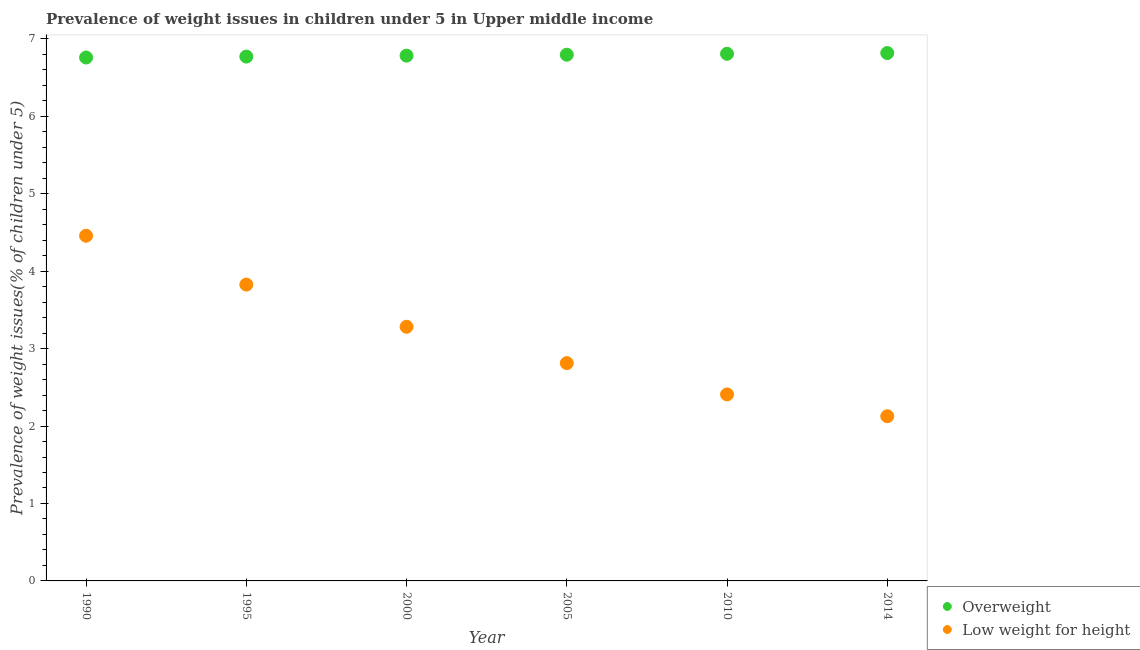Is the number of dotlines equal to the number of legend labels?
Your answer should be compact. Yes. What is the percentage of underweight children in 1990?
Ensure brevity in your answer.  4.46. Across all years, what is the maximum percentage of overweight children?
Provide a succinct answer. 6.82. Across all years, what is the minimum percentage of underweight children?
Your answer should be very brief. 2.13. In which year was the percentage of underweight children minimum?
Offer a very short reply. 2014. What is the total percentage of overweight children in the graph?
Keep it short and to the point. 40.73. What is the difference between the percentage of overweight children in 2005 and that in 2014?
Your response must be concise. -0.02. What is the difference between the percentage of overweight children in 2000 and the percentage of underweight children in 2005?
Keep it short and to the point. 3.97. What is the average percentage of underweight children per year?
Ensure brevity in your answer.  3.15. In the year 1995, what is the difference between the percentage of overweight children and percentage of underweight children?
Offer a terse response. 2.94. In how many years, is the percentage of underweight children greater than 3 %?
Your answer should be very brief. 3. What is the ratio of the percentage of overweight children in 2000 to that in 2014?
Your response must be concise. 1. What is the difference between the highest and the second highest percentage of overweight children?
Offer a terse response. 0.01. What is the difference between the highest and the lowest percentage of underweight children?
Ensure brevity in your answer.  2.33. In how many years, is the percentage of underweight children greater than the average percentage of underweight children taken over all years?
Keep it short and to the point. 3. Is the sum of the percentage of underweight children in 2000 and 2010 greater than the maximum percentage of overweight children across all years?
Offer a terse response. No. Does the percentage of overweight children monotonically increase over the years?
Keep it short and to the point. Yes. Is the percentage of overweight children strictly greater than the percentage of underweight children over the years?
Your answer should be compact. Yes. Is the percentage of overweight children strictly less than the percentage of underweight children over the years?
Give a very brief answer. No. How many dotlines are there?
Your response must be concise. 2. How many years are there in the graph?
Keep it short and to the point. 6. Are the values on the major ticks of Y-axis written in scientific E-notation?
Offer a very short reply. No. How many legend labels are there?
Offer a terse response. 2. What is the title of the graph?
Provide a succinct answer. Prevalence of weight issues in children under 5 in Upper middle income. What is the label or title of the Y-axis?
Provide a succinct answer. Prevalence of weight issues(% of children under 5). What is the Prevalence of weight issues(% of children under 5) in Overweight in 1990?
Provide a short and direct response. 6.76. What is the Prevalence of weight issues(% of children under 5) of Low weight for height in 1990?
Provide a short and direct response. 4.46. What is the Prevalence of weight issues(% of children under 5) of Overweight in 1995?
Offer a very short reply. 6.77. What is the Prevalence of weight issues(% of children under 5) of Low weight for height in 1995?
Make the answer very short. 3.83. What is the Prevalence of weight issues(% of children under 5) in Overweight in 2000?
Your answer should be very brief. 6.78. What is the Prevalence of weight issues(% of children under 5) in Low weight for height in 2000?
Give a very brief answer. 3.28. What is the Prevalence of weight issues(% of children under 5) in Overweight in 2005?
Offer a terse response. 6.8. What is the Prevalence of weight issues(% of children under 5) of Low weight for height in 2005?
Keep it short and to the point. 2.81. What is the Prevalence of weight issues(% of children under 5) of Overweight in 2010?
Ensure brevity in your answer.  6.81. What is the Prevalence of weight issues(% of children under 5) in Low weight for height in 2010?
Make the answer very short. 2.41. What is the Prevalence of weight issues(% of children under 5) of Overweight in 2014?
Ensure brevity in your answer.  6.82. What is the Prevalence of weight issues(% of children under 5) in Low weight for height in 2014?
Ensure brevity in your answer.  2.13. Across all years, what is the maximum Prevalence of weight issues(% of children under 5) in Overweight?
Your answer should be very brief. 6.82. Across all years, what is the maximum Prevalence of weight issues(% of children under 5) in Low weight for height?
Ensure brevity in your answer.  4.46. Across all years, what is the minimum Prevalence of weight issues(% of children under 5) in Overweight?
Provide a short and direct response. 6.76. Across all years, what is the minimum Prevalence of weight issues(% of children under 5) in Low weight for height?
Ensure brevity in your answer.  2.13. What is the total Prevalence of weight issues(% of children under 5) in Overweight in the graph?
Make the answer very short. 40.73. What is the total Prevalence of weight issues(% of children under 5) in Low weight for height in the graph?
Provide a short and direct response. 18.91. What is the difference between the Prevalence of weight issues(% of children under 5) in Overweight in 1990 and that in 1995?
Offer a terse response. -0.01. What is the difference between the Prevalence of weight issues(% of children under 5) in Low weight for height in 1990 and that in 1995?
Your response must be concise. 0.63. What is the difference between the Prevalence of weight issues(% of children under 5) of Overweight in 1990 and that in 2000?
Provide a succinct answer. -0.02. What is the difference between the Prevalence of weight issues(% of children under 5) in Low weight for height in 1990 and that in 2000?
Your response must be concise. 1.18. What is the difference between the Prevalence of weight issues(% of children under 5) in Overweight in 1990 and that in 2005?
Provide a short and direct response. -0.04. What is the difference between the Prevalence of weight issues(% of children under 5) of Low weight for height in 1990 and that in 2005?
Your answer should be compact. 1.65. What is the difference between the Prevalence of weight issues(% of children under 5) in Overweight in 1990 and that in 2010?
Your answer should be compact. -0.05. What is the difference between the Prevalence of weight issues(% of children under 5) of Low weight for height in 1990 and that in 2010?
Your answer should be very brief. 2.05. What is the difference between the Prevalence of weight issues(% of children under 5) in Overweight in 1990 and that in 2014?
Offer a terse response. -0.06. What is the difference between the Prevalence of weight issues(% of children under 5) of Low weight for height in 1990 and that in 2014?
Offer a very short reply. 2.33. What is the difference between the Prevalence of weight issues(% of children under 5) of Overweight in 1995 and that in 2000?
Your answer should be very brief. -0.01. What is the difference between the Prevalence of weight issues(% of children under 5) in Low weight for height in 1995 and that in 2000?
Provide a short and direct response. 0.54. What is the difference between the Prevalence of weight issues(% of children under 5) in Overweight in 1995 and that in 2005?
Keep it short and to the point. -0.02. What is the difference between the Prevalence of weight issues(% of children under 5) in Low weight for height in 1995 and that in 2005?
Make the answer very short. 1.01. What is the difference between the Prevalence of weight issues(% of children under 5) in Overweight in 1995 and that in 2010?
Your answer should be compact. -0.04. What is the difference between the Prevalence of weight issues(% of children under 5) in Low weight for height in 1995 and that in 2010?
Offer a very short reply. 1.42. What is the difference between the Prevalence of weight issues(% of children under 5) in Overweight in 1995 and that in 2014?
Provide a short and direct response. -0.05. What is the difference between the Prevalence of weight issues(% of children under 5) of Low weight for height in 1995 and that in 2014?
Ensure brevity in your answer.  1.7. What is the difference between the Prevalence of weight issues(% of children under 5) in Overweight in 2000 and that in 2005?
Provide a short and direct response. -0.01. What is the difference between the Prevalence of weight issues(% of children under 5) of Low weight for height in 2000 and that in 2005?
Offer a terse response. 0.47. What is the difference between the Prevalence of weight issues(% of children under 5) in Overweight in 2000 and that in 2010?
Your answer should be very brief. -0.02. What is the difference between the Prevalence of weight issues(% of children under 5) in Low weight for height in 2000 and that in 2010?
Provide a short and direct response. 0.87. What is the difference between the Prevalence of weight issues(% of children under 5) of Overweight in 2000 and that in 2014?
Make the answer very short. -0.03. What is the difference between the Prevalence of weight issues(% of children under 5) in Low weight for height in 2000 and that in 2014?
Keep it short and to the point. 1.16. What is the difference between the Prevalence of weight issues(% of children under 5) of Overweight in 2005 and that in 2010?
Ensure brevity in your answer.  -0.01. What is the difference between the Prevalence of weight issues(% of children under 5) of Low weight for height in 2005 and that in 2010?
Ensure brevity in your answer.  0.4. What is the difference between the Prevalence of weight issues(% of children under 5) of Overweight in 2005 and that in 2014?
Your response must be concise. -0.02. What is the difference between the Prevalence of weight issues(% of children under 5) of Low weight for height in 2005 and that in 2014?
Make the answer very short. 0.69. What is the difference between the Prevalence of weight issues(% of children under 5) of Overweight in 2010 and that in 2014?
Your answer should be very brief. -0.01. What is the difference between the Prevalence of weight issues(% of children under 5) of Low weight for height in 2010 and that in 2014?
Your answer should be very brief. 0.28. What is the difference between the Prevalence of weight issues(% of children under 5) of Overweight in 1990 and the Prevalence of weight issues(% of children under 5) of Low weight for height in 1995?
Offer a terse response. 2.93. What is the difference between the Prevalence of weight issues(% of children under 5) of Overweight in 1990 and the Prevalence of weight issues(% of children under 5) of Low weight for height in 2000?
Give a very brief answer. 3.48. What is the difference between the Prevalence of weight issues(% of children under 5) of Overweight in 1990 and the Prevalence of weight issues(% of children under 5) of Low weight for height in 2005?
Provide a succinct answer. 3.95. What is the difference between the Prevalence of weight issues(% of children under 5) of Overweight in 1990 and the Prevalence of weight issues(% of children under 5) of Low weight for height in 2010?
Give a very brief answer. 4.35. What is the difference between the Prevalence of weight issues(% of children under 5) in Overweight in 1990 and the Prevalence of weight issues(% of children under 5) in Low weight for height in 2014?
Offer a terse response. 4.63. What is the difference between the Prevalence of weight issues(% of children under 5) of Overweight in 1995 and the Prevalence of weight issues(% of children under 5) of Low weight for height in 2000?
Ensure brevity in your answer.  3.49. What is the difference between the Prevalence of weight issues(% of children under 5) of Overweight in 1995 and the Prevalence of weight issues(% of children under 5) of Low weight for height in 2005?
Provide a succinct answer. 3.96. What is the difference between the Prevalence of weight issues(% of children under 5) in Overweight in 1995 and the Prevalence of weight issues(% of children under 5) in Low weight for height in 2010?
Your answer should be very brief. 4.36. What is the difference between the Prevalence of weight issues(% of children under 5) of Overweight in 1995 and the Prevalence of weight issues(% of children under 5) of Low weight for height in 2014?
Your answer should be compact. 4.64. What is the difference between the Prevalence of weight issues(% of children under 5) of Overweight in 2000 and the Prevalence of weight issues(% of children under 5) of Low weight for height in 2005?
Offer a terse response. 3.97. What is the difference between the Prevalence of weight issues(% of children under 5) in Overweight in 2000 and the Prevalence of weight issues(% of children under 5) in Low weight for height in 2010?
Keep it short and to the point. 4.37. What is the difference between the Prevalence of weight issues(% of children under 5) of Overweight in 2000 and the Prevalence of weight issues(% of children under 5) of Low weight for height in 2014?
Provide a short and direct response. 4.66. What is the difference between the Prevalence of weight issues(% of children under 5) of Overweight in 2005 and the Prevalence of weight issues(% of children under 5) of Low weight for height in 2010?
Provide a short and direct response. 4.39. What is the difference between the Prevalence of weight issues(% of children under 5) of Overweight in 2005 and the Prevalence of weight issues(% of children under 5) of Low weight for height in 2014?
Your answer should be compact. 4.67. What is the difference between the Prevalence of weight issues(% of children under 5) of Overweight in 2010 and the Prevalence of weight issues(% of children under 5) of Low weight for height in 2014?
Give a very brief answer. 4.68. What is the average Prevalence of weight issues(% of children under 5) in Overweight per year?
Your response must be concise. 6.79. What is the average Prevalence of weight issues(% of children under 5) of Low weight for height per year?
Your response must be concise. 3.15. In the year 1990, what is the difference between the Prevalence of weight issues(% of children under 5) of Overweight and Prevalence of weight issues(% of children under 5) of Low weight for height?
Your answer should be very brief. 2.3. In the year 1995, what is the difference between the Prevalence of weight issues(% of children under 5) in Overweight and Prevalence of weight issues(% of children under 5) in Low weight for height?
Offer a very short reply. 2.94. In the year 2000, what is the difference between the Prevalence of weight issues(% of children under 5) of Overweight and Prevalence of weight issues(% of children under 5) of Low weight for height?
Ensure brevity in your answer.  3.5. In the year 2005, what is the difference between the Prevalence of weight issues(% of children under 5) in Overweight and Prevalence of weight issues(% of children under 5) in Low weight for height?
Offer a very short reply. 3.98. In the year 2010, what is the difference between the Prevalence of weight issues(% of children under 5) in Overweight and Prevalence of weight issues(% of children under 5) in Low weight for height?
Offer a very short reply. 4.4. In the year 2014, what is the difference between the Prevalence of weight issues(% of children under 5) of Overweight and Prevalence of weight issues(% of children under 5) of Low weight for height?
Your response must be concise. 4.69. What is the ratio of the Prevalence of weight issues(% of children under 5) of Overweight in 1990 to that in 1995?
Your answer should be very brief. 1. What is the ratio of the Prevalence of weight issues(% of children under 5) of Low weight for height in 1990 to that in 1995?
Make the answer very short. 1.16. What is the ratio of the Prevalence of weight issues(% of children under 5) in Overweight in 1990 to that in 2000?
Provide a succinct answer. 1. What is the ratio of the Prevalence of weight issues(% of children under 5) of Low weight for height in 1990 to that in 2000?
Your answer should be very brief. 1.36. What is the ratio of the Prevalence of weight issues(% of children under 5) in Overweight in 1990 to that in 2005?
Give a very brief answer. 0.99. What is the ratio of the Prevalence of weight issues(% of children under 5) of Low weight for height in 1990 to that in 2005?
Keep it short and to the point. 1.58. What is the ratio of the Prevalence of weight issues(% of children under 5) in Low weight for height in 1990 to that in 2010?
Give a very brief answer. 1.85. What is the ratio of the Prevalence of weight issues(% of children under 5) in Overweight in 1990 to that in 2014?
Offer a terse response. 0.99. What is the ratio of the Prevalence of weight issues(% of children under 5) of Low weight for height in 1990 to that in 2014?
Provide a short and direct response. 2.1. What is the ratio of the Prevalence of weight issues(% of children under 5) in Low weight for height in 1995 to that in 2000?
Make the answer very short. 1.17. What is the ratio of the Prevalence of weight issues(% of children under 5) of Overweight in 1995 to that in 2005?
Your answer should be compact. 1. What is the ratio of the Prevalence of weight issues(% of children under 5) in Low weight for height in 1995 to that in 2005?
Provide a short and direct response. 1.36. What is the ratio of the Prevalence of weight issues(% of children under 5) in Low weight for height in 1995 to that in 2010?
Offer a terse response. 1.59. What is the ratio of the Prevalence of weight issues(% of children under 5) in Low weight for height in 1995 to that in 2014?
Ensure brevity in your answer.  1.8. What is the ratio of the Prevalence of weight issues(% of children under 5) in Low weight for height in 2000 to that in 2005?
Your answer should be compact. 1.17. What is the ratio of the Prevalence of weight issues(% of children under 5) of Overweight in 2000 to that in 2010?
Give a very brief answer. 1. What is the ratio of the Prevalence of weight issues(% of children under 5) of Low weight for height in 2000 to that in 2010?
Offer a very short reply. 1.36. What is the ratio of the Prevalence of weight issues(% of children under 5) in Overweight in 2000 to that in 2014?
Provide a succinct answer. 0.99. What is the ratio of the Prevalence of weight issues(% of children under 5) of Low weight for height in 2000 to that in 2014?
Ensure brevity in your answer.  1.54. What is the ratio of the Prevalence of weight issues(% of children under 5) of Low weight for height in 2005 to that in 2010?
Offer a very short reply. 1.17. What is the ratio of the Prevalence of weight issues(% of children under 5) in Low weight for height in 2005 to that in 2014?
Offer a very short reply. 1.32. What is the ratio of the Prevalence of weight issues(% of children under 5) of Overweight in 2010 to that in 2014?
Provide a succinct answer. 1. What is the ratio of the Prevalence of weight issues(% of children under 5) in Low weight for height in 2010 to that in 2014?
Make the answer very short. 1.13. What is the difference between the highest and the second highest Prevalence of weight issues(% of children under 5) in Overweight?
Offer a terse response. 0.01. What is the difference between the highest and the second highest Prevalence of weight issues(% of children under 5) of Low weight for height?
Offer a very short reply. 0.63. What is the difference between the highest and the lowest Prevalence of weight issues(% of children under 5) of Overweight?
Your answer should be compact. 0.06. What is the difference between the highest and the lowest Prevalence of weight issues(% of children under 5) of Low weight for height?
Keep it short and to the point. 2.33. 